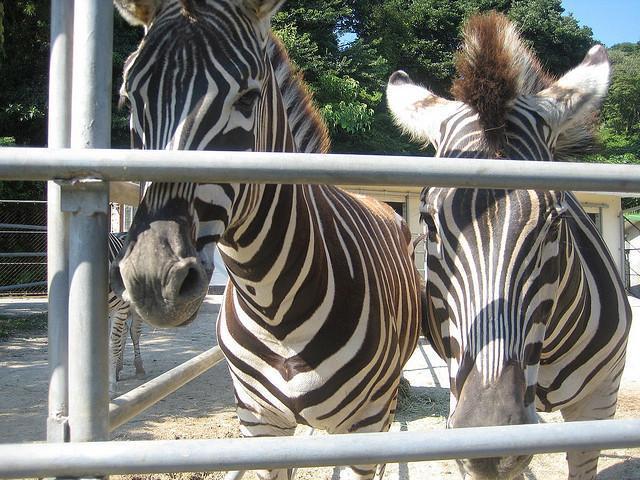How many zebras can be seen?
Give a very brief answer. 3. How many people are cutting cake in the image?
Give a very brief answer. 0. 